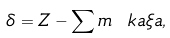Convert formula to latex. <formula><loc_0><loc_0><loc_500><loc_500>\delta = Z - \sum m \ k a \xi a ,</formula> 